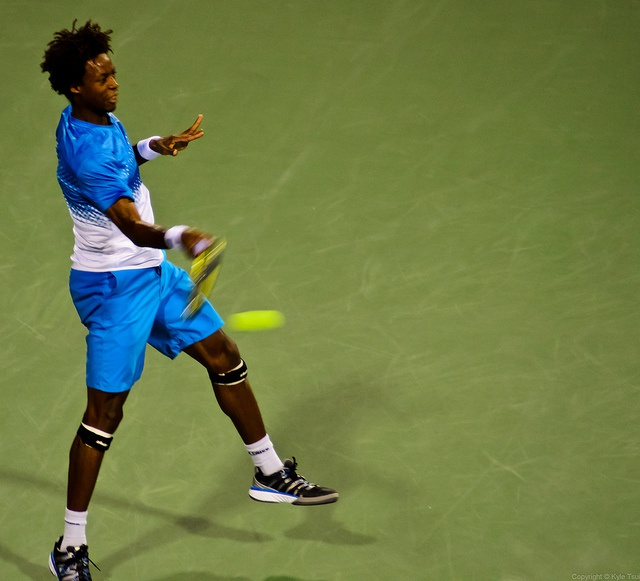Describe the objects in this image and their specific colors. I can see people in darkgreen, black, blue, and gray tones, tennis racket in darkgreen, olive, and blue tones, and sports ball in darkgreen, khaki, yellow, and olive tones in this image. 